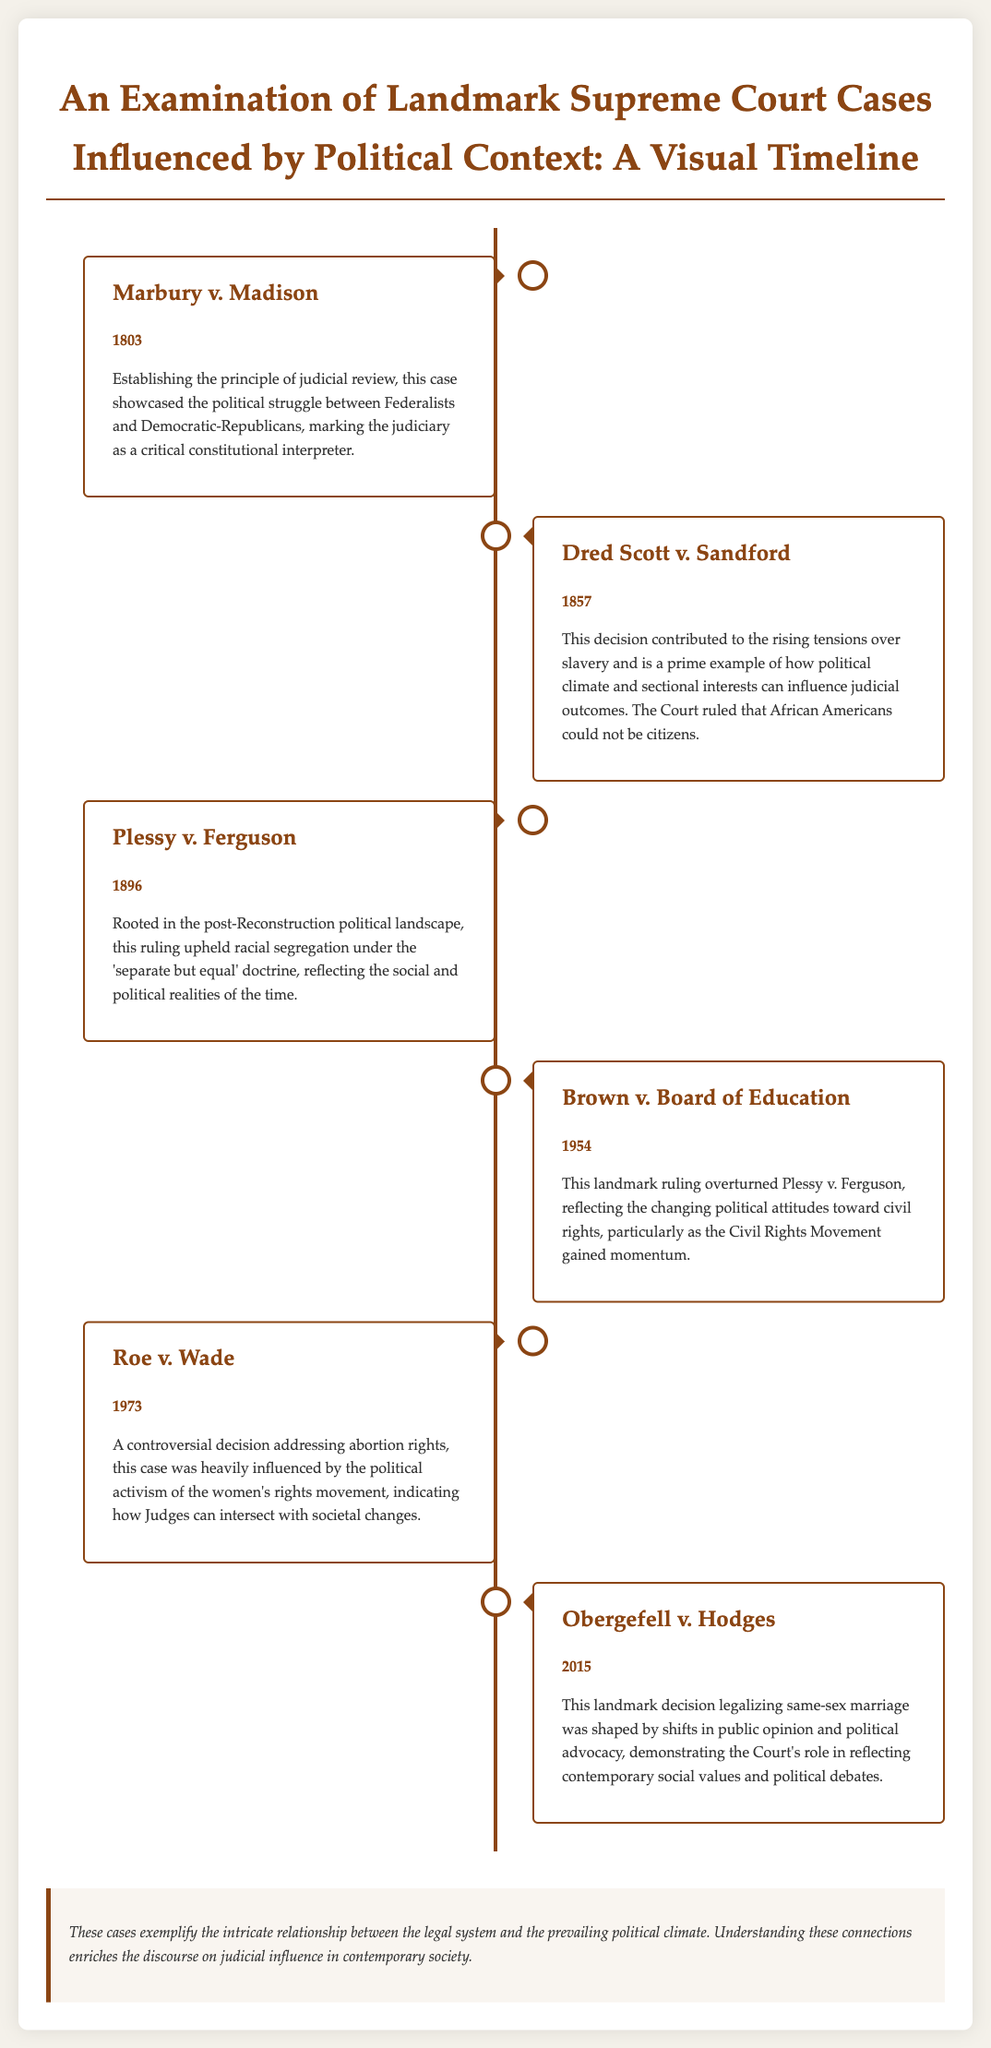What is the title of the document? The title is presented prominently at the top of the document, which is "An Examination of Landmark Supreme Court Cases Influenced by Political Context: A Visual Timeline."
Answer: An Examination of Landmark Supreme Court Cases Influenced by Political Context: A Visual Timeline What year was Marbury v. Madison decided? The year is mentioned directly under the case title, stating 1803 for Marbury v. Madison.
Answer: 1803 Which case overturned Plessy v. Ferguson? The document specifies Brown v. Board of Education as the case that overturned Plessy v. Ferguson.
Answer: Brown v. Board of Education In what year was Roe v. Wade decided? The publication gives the year as 1973 for Roe v. Wade.
Answer: 1973 What principle was established in Marbury v. Madison? The document states that the case established the principle of judicial review.
Answer: judicial review How did Obergefell v. Hodges relate to public opinion? It mentions that Obergefell v. Hodges was shaped by shifts in public opinion and political advocacy.
Answer: shifts in public opinion What social movement influenced Roe v. Wade? The women's rights movement is noted as the influence behind Roe v. Wade.
Answer: women's rights movement What is the overall conclusion about the cases discussed? The summary emphasizes the relationship between the legal system and the political climate.
Answer: judicial influence in contemporary society Which case ruled that African Americans could not be citizens? Dred Scott v. Sandford is identified as the case that made this ruling.
Answer: Dred Scott v. Sandford 